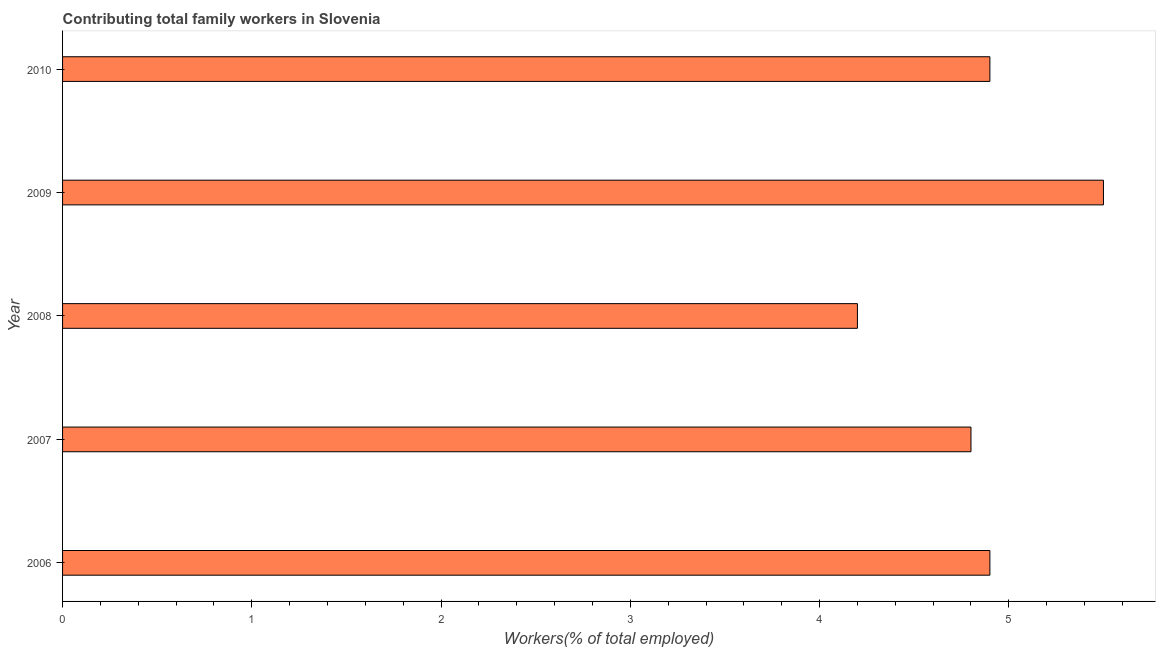Does the graph contain grids?
Make the answer very short. No. What is the title of the graph?
Offer a terse response. Contributing total family workers in Slovenia. What is the label or title of the X-axis?
Your answer should be very brief. Workers(% of total employed). What is the contributing family workers in 2009?
Your answer should be compact. 5.5. Across all years, what is the minimum contributing family workers?
Offer a very short reply. 4.2. In which year was the contributing family workers maximum?
Offer a terse response. 2009. What is the sum of the contributing family workers?
Offer a very short reply. 24.3. What is the average contributing family workers per year?
Offer a very short reply. 4.86. What is the median contributing family workers?
Provide a succinct answer. 4.9. In how many years, is the contributing family workers greater than 2.6 %?
Your answer should be very brief. 5. Do a majority of the years between 2008 and 2010 (inclusive) have contributing family workers greater than 4 %?
Your response must be concise. Yes. What is the ratio of the contributing family workers in 2006 to that in 2008?
Offer a terse response. 1.17. Is the contributing family workers in 2007 less than that in 2009?
Give a very brief answer. Yes. What is the difference between the highest and the lowest contributing family workers?
Offer a very short reply. 1.3. In how many years, is the contributing family workers greater than the average contributing family workers taken over all years?
Offer a terse response. 3. What is the difference between two consecutive major ticks on the X-axis?
Offer a very short reply. 1. What is the Workers(% of total employed) of 2006?
Offer a very short reply. 4.9. What is the Workers(% of total employed) in 2007?
Your answer should be very brief. 4.8. What is the Workers(% of total employed) in 2008?
Give a very brief answer. 4.2. What is the Workers(% of total employed) of 2009?
Provide a short and direct response. 5.5. What is the Workers(% of total employed) of 2010?
Offer a terse response. 4.9. What is the difference between the Workers(% of total employed) in 2006 and 2008?
Your answer should be compact. 0.7. What is the difference between the Workers(% of total employed) in 2006 and 2009?
Offer a terse response. -0.6. What is the difference between the Workers(% of total employed) in 2007 and 2010?
Provide a short and direct response. -0.1. What is the difference between the Workers(% of total employed) in 2008 and 2009?
Offer a very short reply. -1.3. What is the difference between the Workers(% of total employed) in 2009 and 2010?
Keep it short and to the point. 0.6. What is the ratio of the Workers(% of total employed) in 2006 to that in 2008?
Give a very brief answer. 1.17. What is the ratio of the Workers(% of total employed) in 2006 to that in 2009?
Provide a short and direct response. 0.89. What is the ratio of the Workers(% of total employed) in 2006 to that in 2010?
Ensure brevity in your answer.  1. What is the ratio of the Workers(% of total employed) in 2007 to that in 2008?
Offer a very short reply. 1.14. What is the ratio of the Workers(% of total employed) in 2007 to that in 2009?
Your answer should be very brief. 0.87. What is the ratio of the Workers(% of total employed) in 2007 to that in 2010?
Your answer should be very brief. 0.98. What is the ratio of the Workers(% of total employed) in 2008 to that in 2009?
Provide a short and direct response. 0.76. What is the ratio of the Workers(% of total employed) in 2008 to that in 2010?
Your answer should be compact. 0.86. What is the ratio of the Workers(% of total employed) in 2009 to that in 2010?
Give a very brief answer. 1.12. 